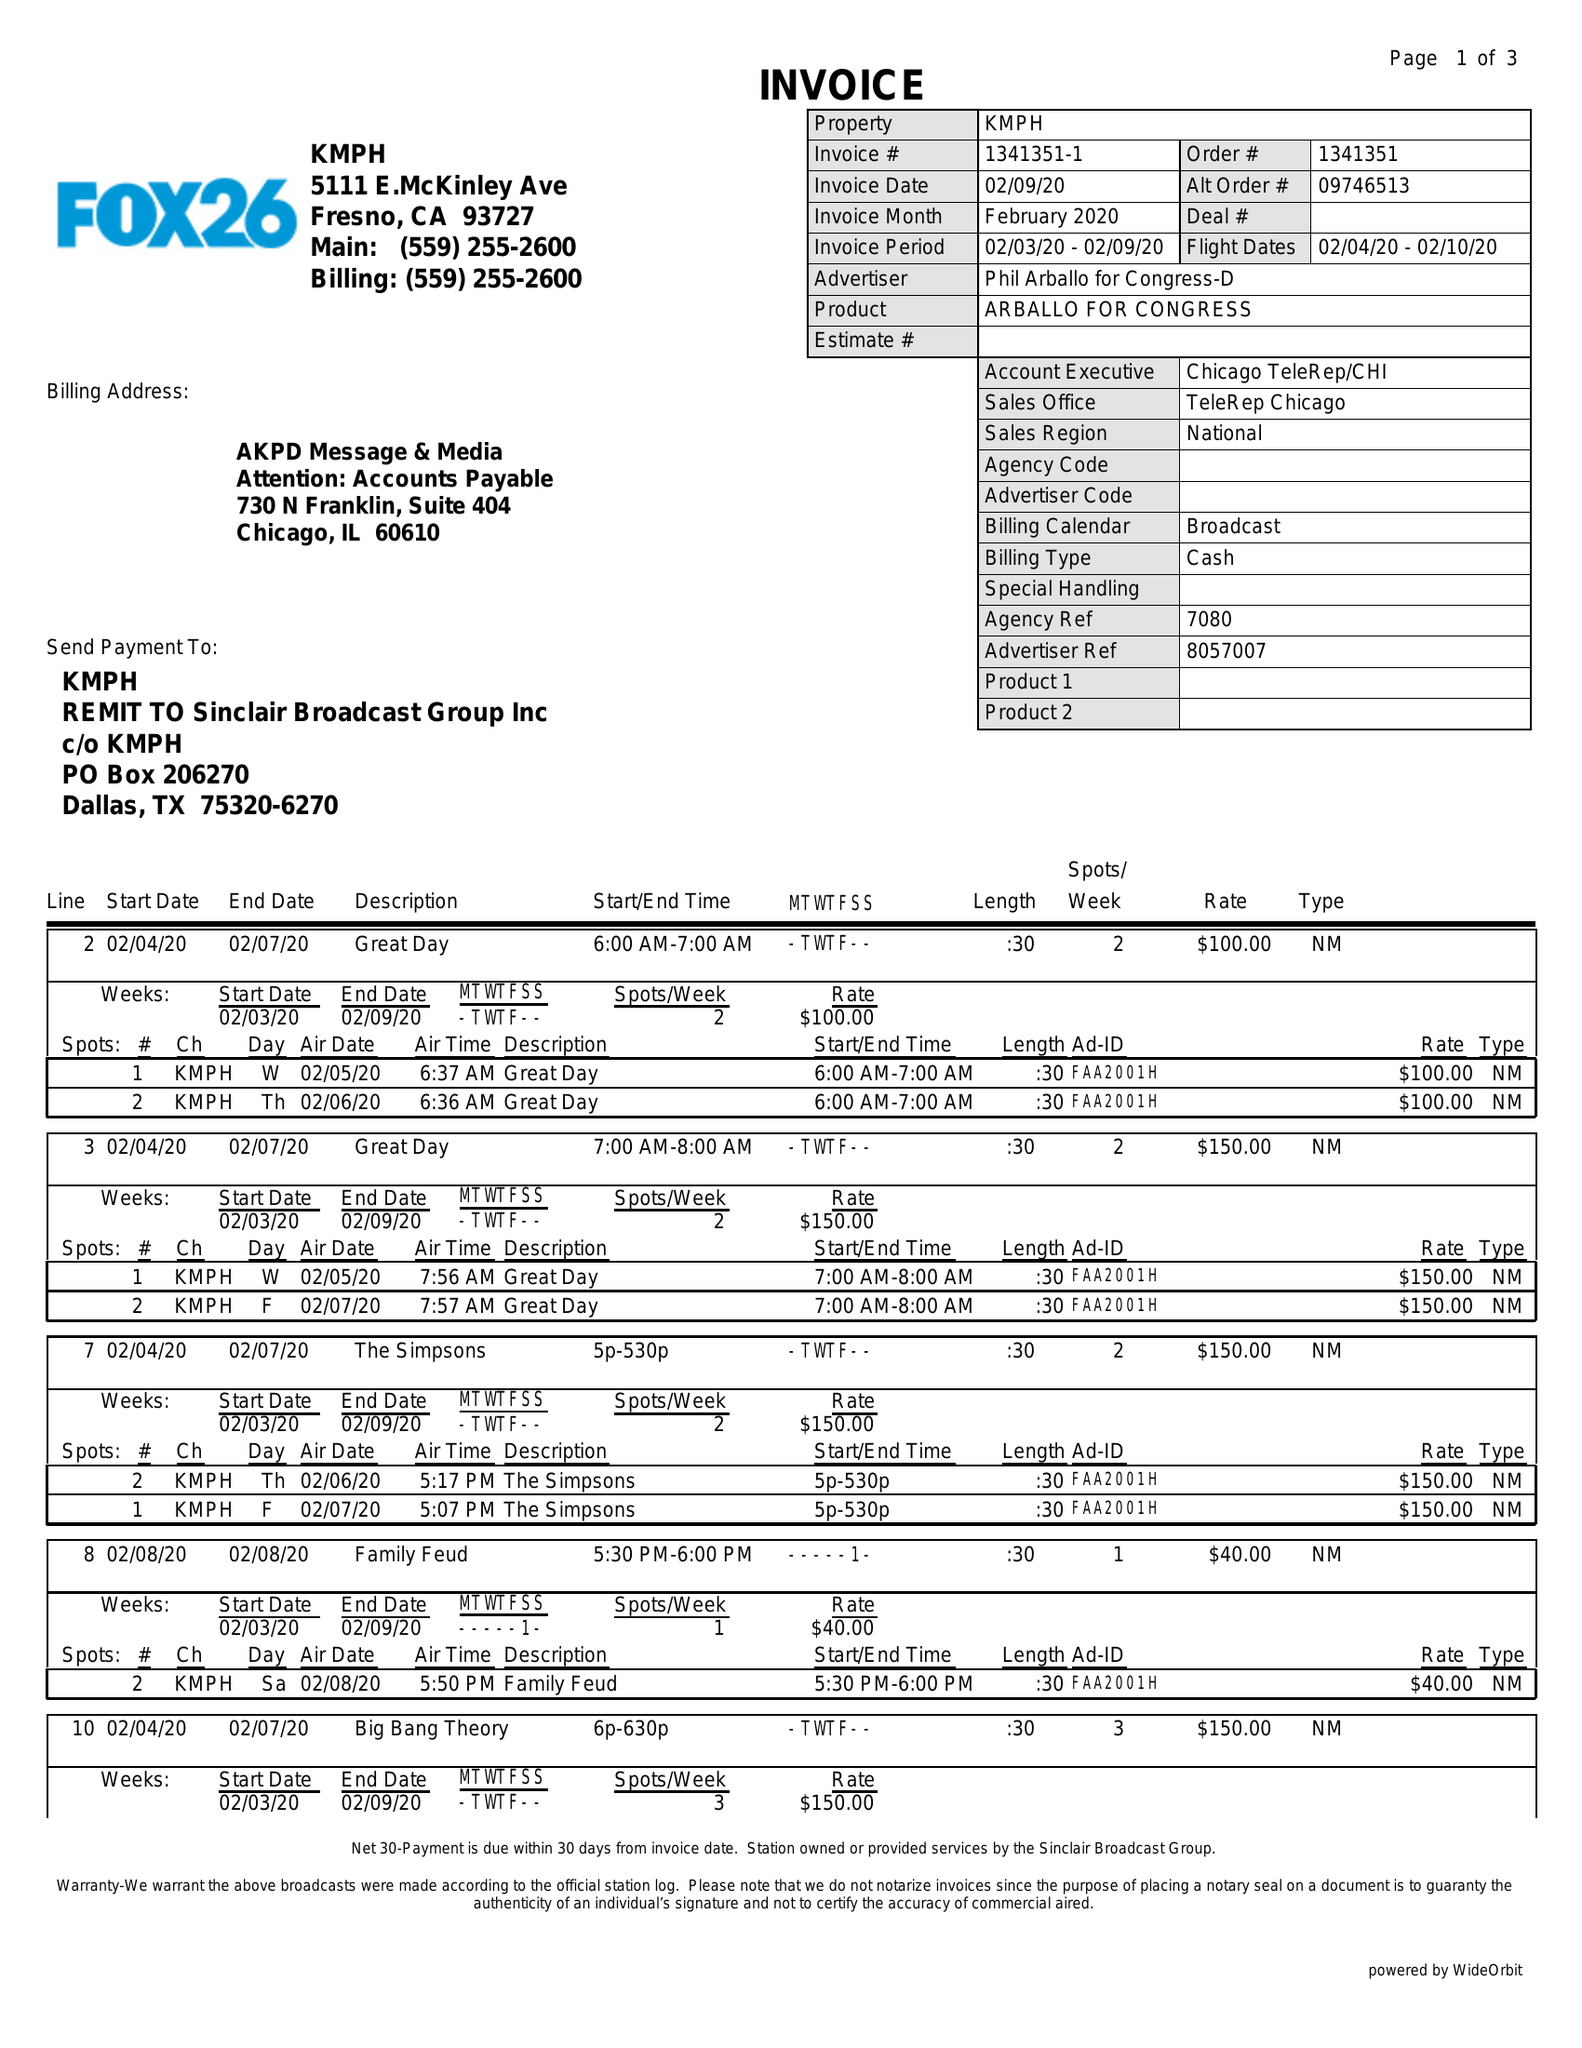What is the value for the flight_from?
Answer the question using a single word or phrase. 02/04/20 